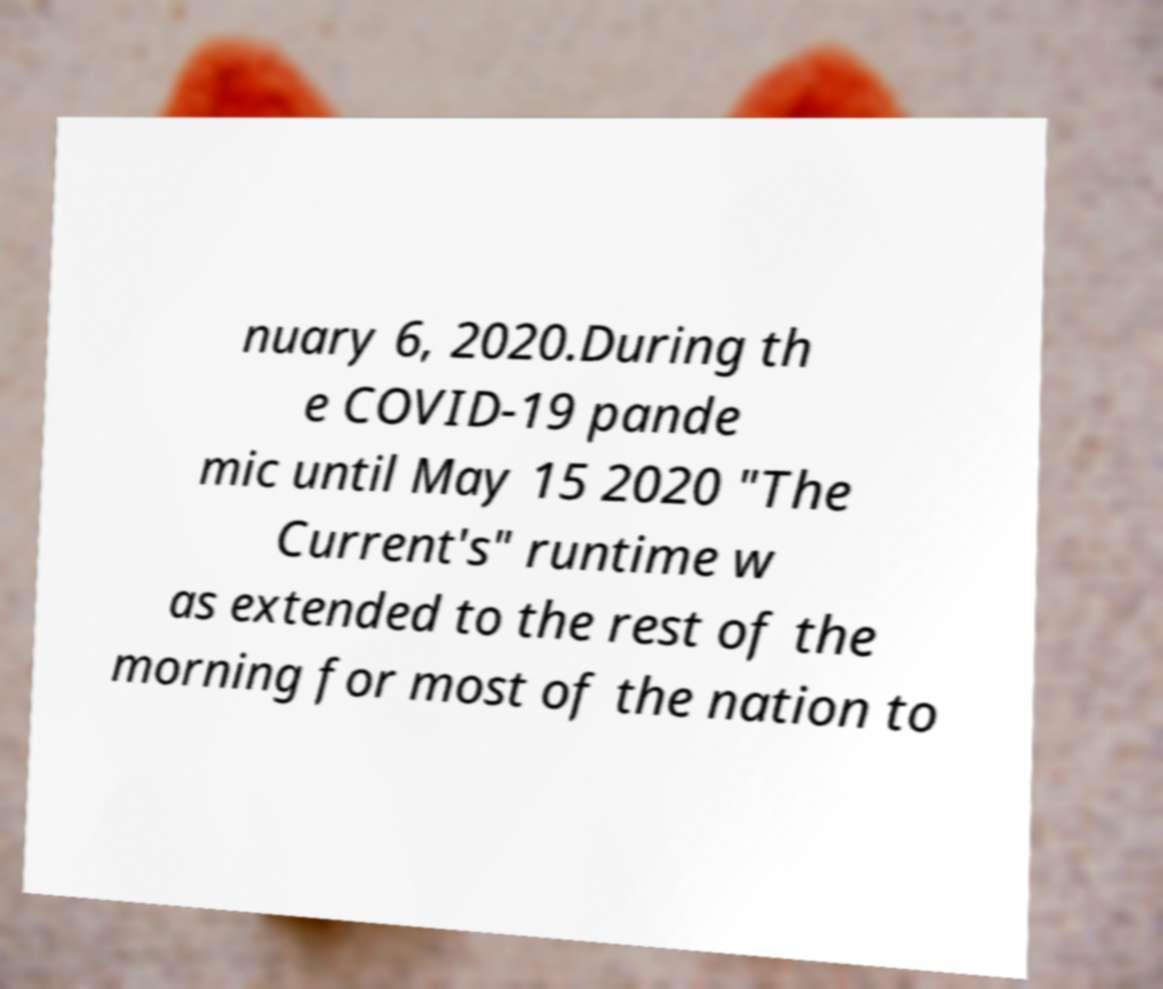I need the written content from this picture converted into text. Can you do that? nuary 6, 2020.During th e COVID-19 pande mic until May 15 2020 "The Current's" runtime w as extended to the rest of the morning for most of the nation to 